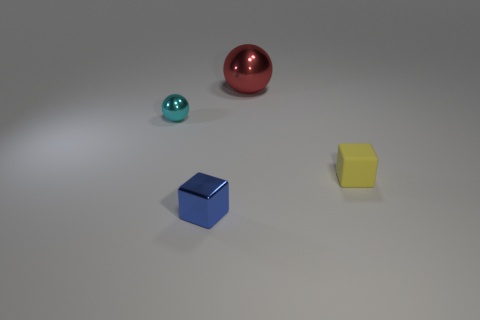Is there any other thing that is the same material as the yellow thing?
Your answer should be very brief. No. Is the color of the small metallic sphere the same as the rubber cube?
Your answer should be very brief. No. What number of metallic objects are tiny blue things or spheres?
Offer a very short reply. 3. There is a ball to the right of the cube on the left side of the tiny rubber cube; is there a tiny sphere that is behind it?
Make the answer very short. No. What is the size of the blue block that is the same material as the tiny cyan ball?
Your response must be concise. Small. There is a cyan ball; are there any cyan metallic things in front of it?
Your response must be concise. No. There is a tiny metallic thing that is behind the small matte object; is there a big red shiny thing that is in front of it?
Your answer should be very brief. No. There is a metallic thing in front of the yellow object; is it the same size as the ball that is right of the small cyan thing?
Offer a very short reply. No. How many big objects are yellow matte objects or shiny cubes?
Give a very brief answer. 0. What material is the object behind the small metal thing that is behind the tiny yellow matte thing?
Keep it short and to the point. Metal. 